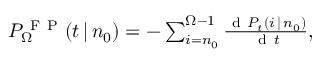Convert formula to latex. <formula><loc_0><loc_0><loc_500><loc_500>\begin{array} { r } { P _ { \Omega } ^ { F P } ( t \, | \, n _ { 0 } ) = - \sum _ { i = n _ { 0 } } ^ { \Omega - 1 } \frac { d P _ { t } ( i \, | \, n _ { 0 } ) } { d t } , } \end{array}</formula> 